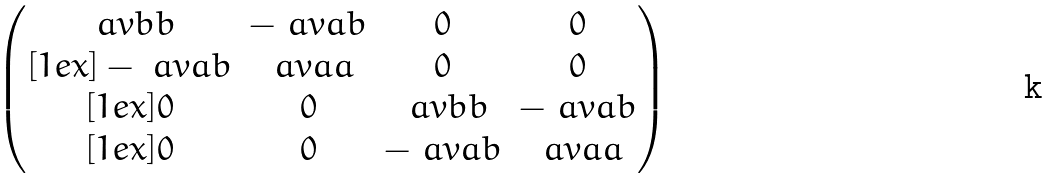Convert formula to latex. <formula><loc_0><loc_0><loc_500><loc_500>\begin{pmatrix} \ a v b b & - \ a v a b & 0 & 0 \\ [ 1 e x ] - \ a v a b & \ a v a a & 0 & 0 \\ [ 1 e x ] 0 & 0 & \ a v b b & - \ a v a b \\ [ 1 e x ] 0 & 0 & - \ a v a b & \ a v a a \end{pmatrix}</formula> 